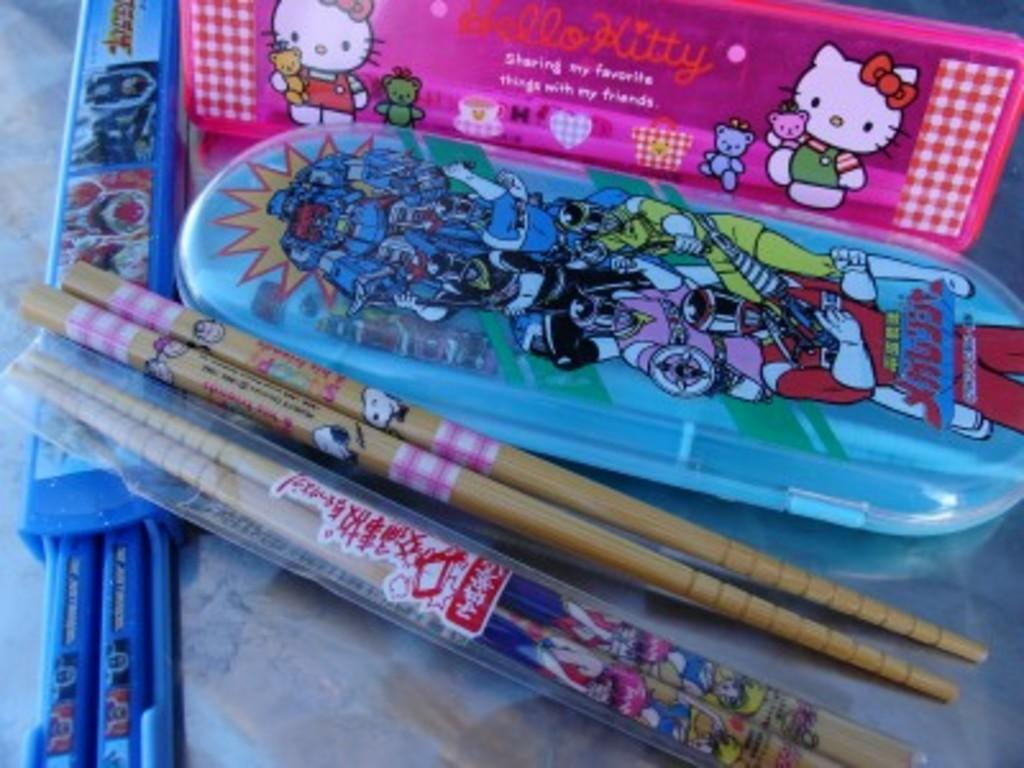What colors are the boxes in the image? There is a pink box and a blue box in the image. What objects are made of wood in the image? There are two wooden sticks in the image. What is the color of the blue object in the image? The blue object in the image is not specified, but it could be the blue box. Can you see any birds taking a bath in the image? There are no birds or baths present in the image. 